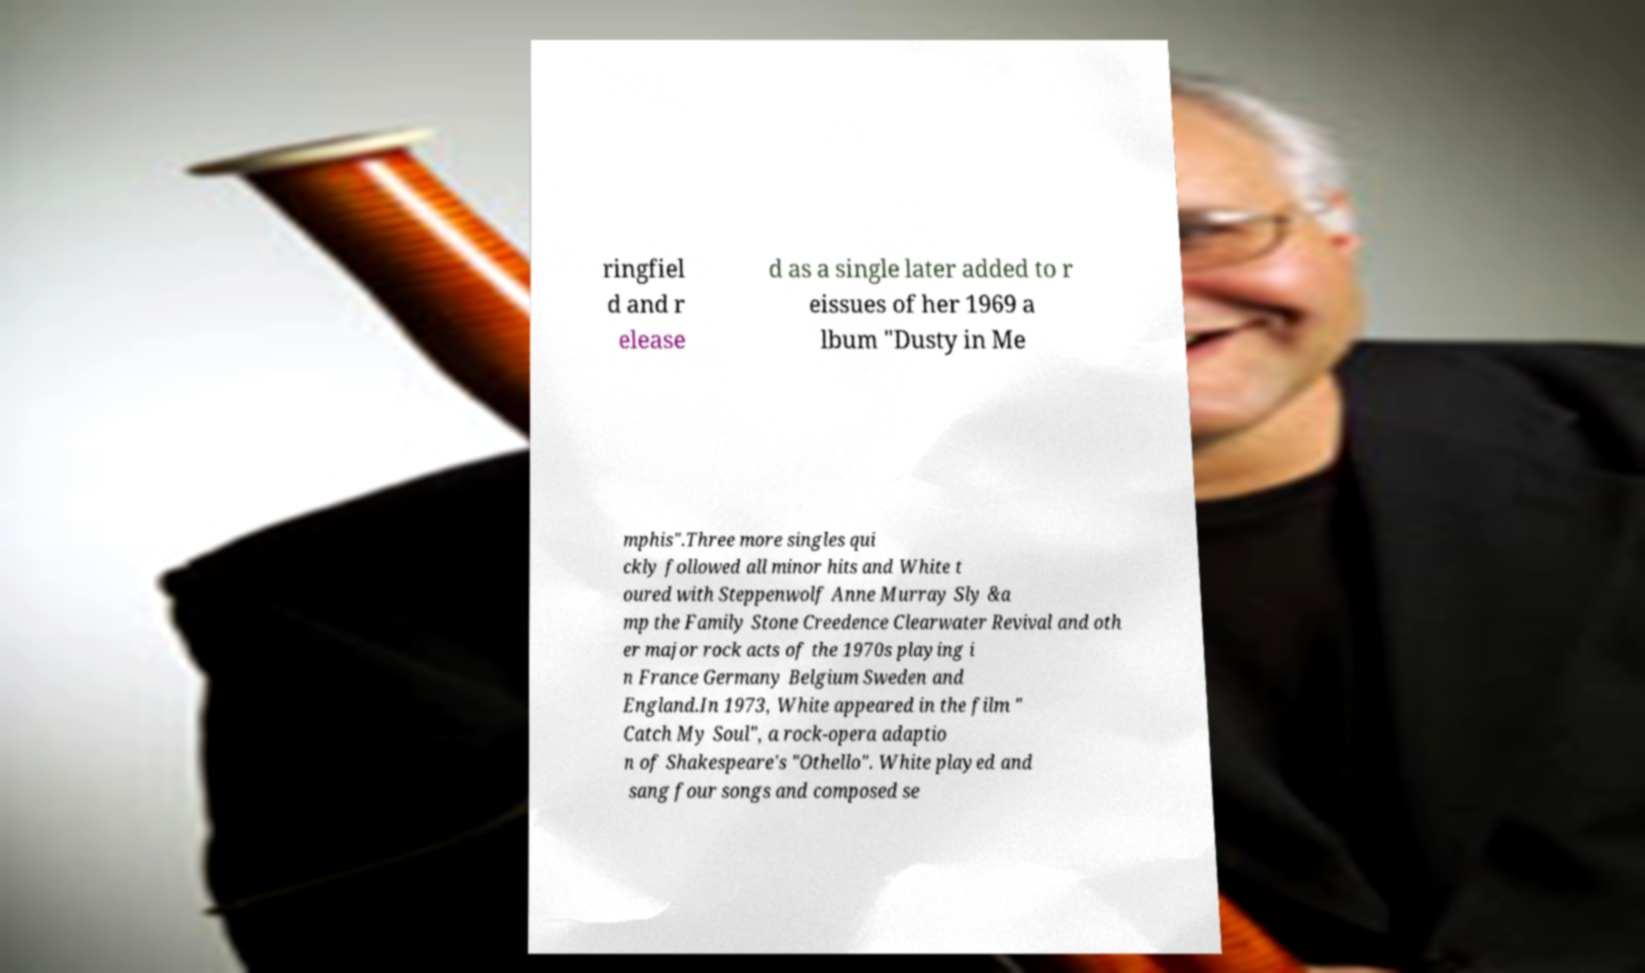Please identify and transcribe the text found in this image. ringfiel d and r elease d as a single later added to r eissues of her 1969 a lbum "Dusty in Me mphis".Three more singles qui ckly followed all minor hits and White t oured with Steppenwolf Anne Murray Sly &a mp the Family Stone Creedence Clearwater Revival and oth er major rock acts of the 1970s playing i n France Germany Belgium Sweden and England.In 1973, White appeared in the film " Catch My Soul", a rock-opera adaptio n of Shakespeare's "Othello". White played and sang four songs and composed se 